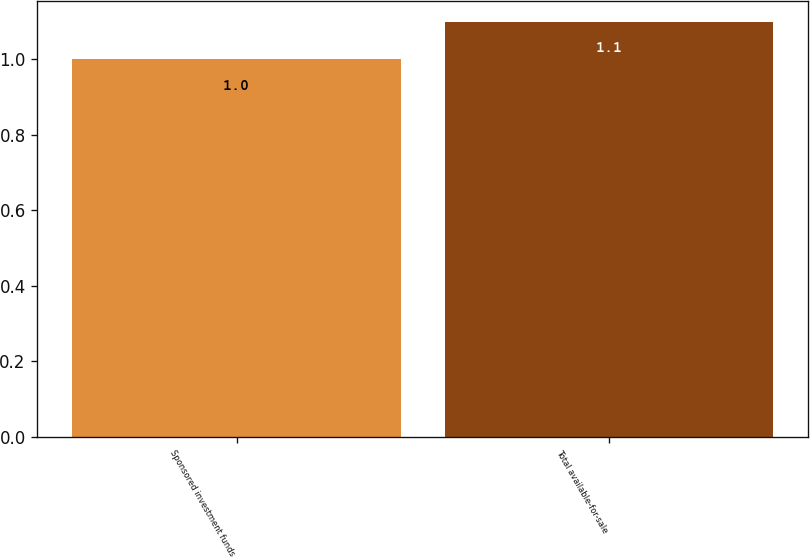Convert chart to OTSL. <chart><loc_0><loc_0><loc_500><loc_500><bar_chart><fcel>Sponsored investment funds<fcel>Total available-for-sale<nl><fcel>1<fcel>1.1<nl></chart> 